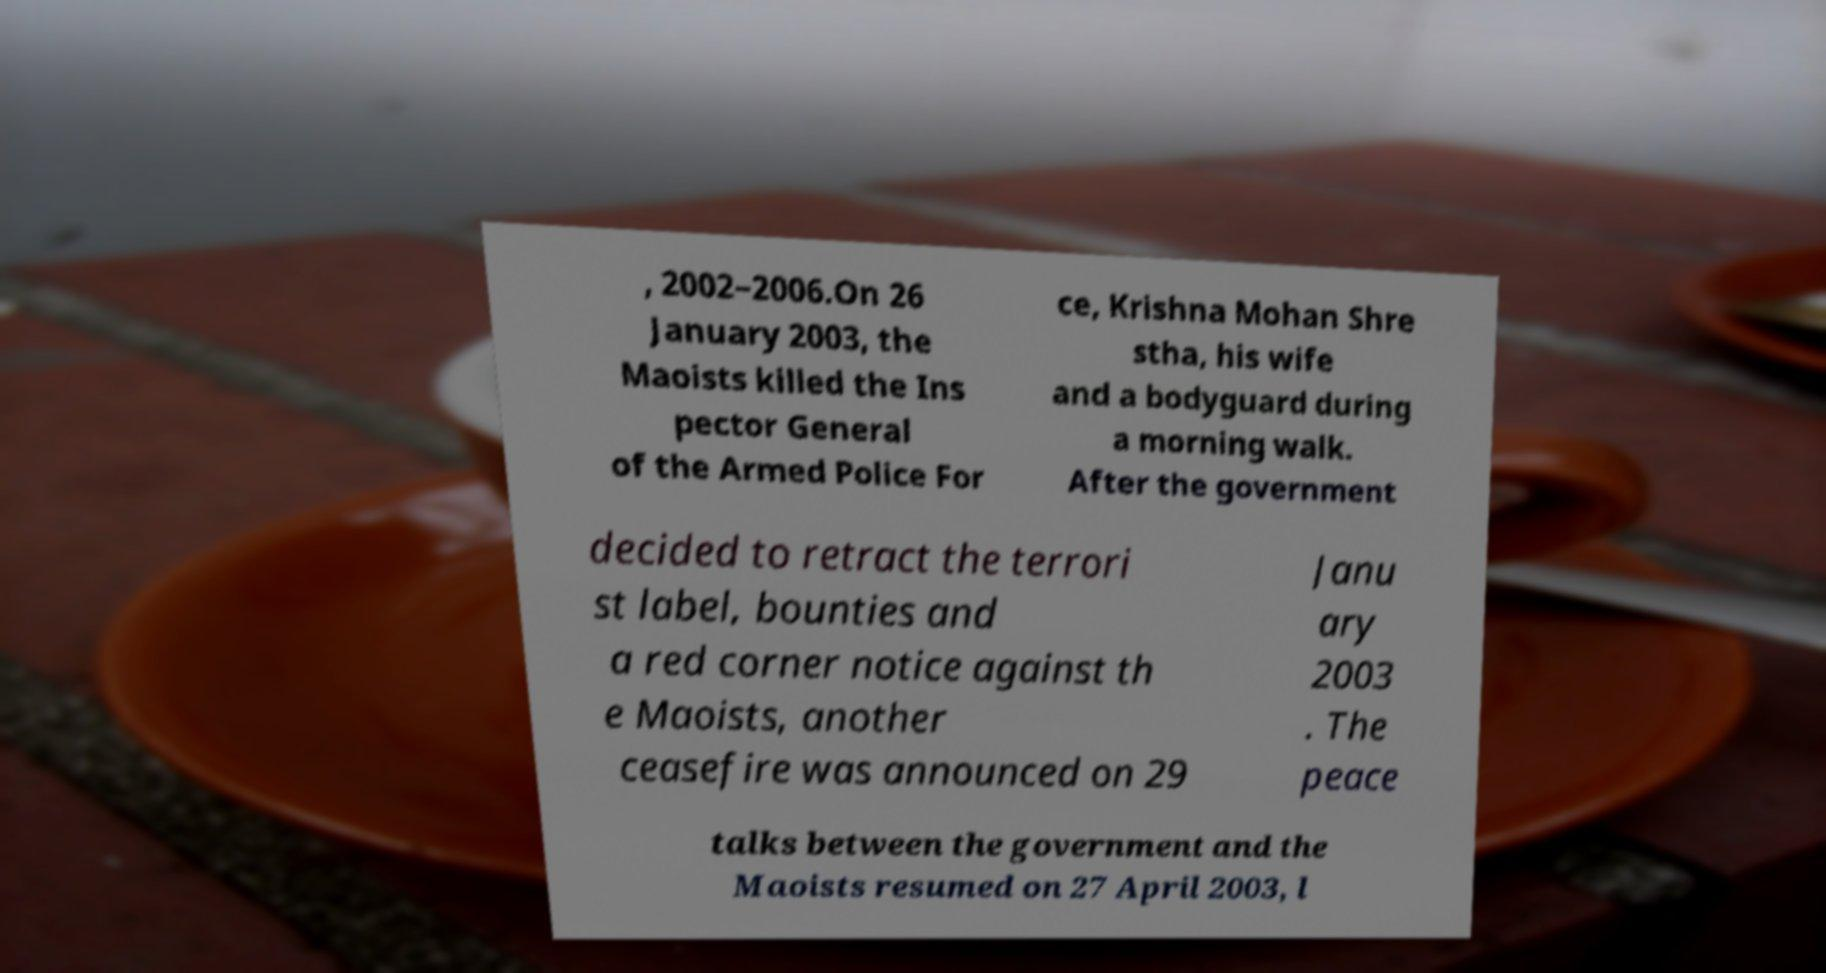Please identify and transcribe the text found in this image. , 2002–2006.On 26 January 2003, the Maoists killed the Ins pector General of the Armed Police For ce, Krishna Mohan Shre stha, his wife and a bodyguard during a morning walk. After the government decided to retract the terrori st label, bounties and a red corner notice against th e Maoists, another ceasefire was announced on 29 Janu ary 2003 . The peace talks between the government and the Maoists resumed on 27 April 2003, l 